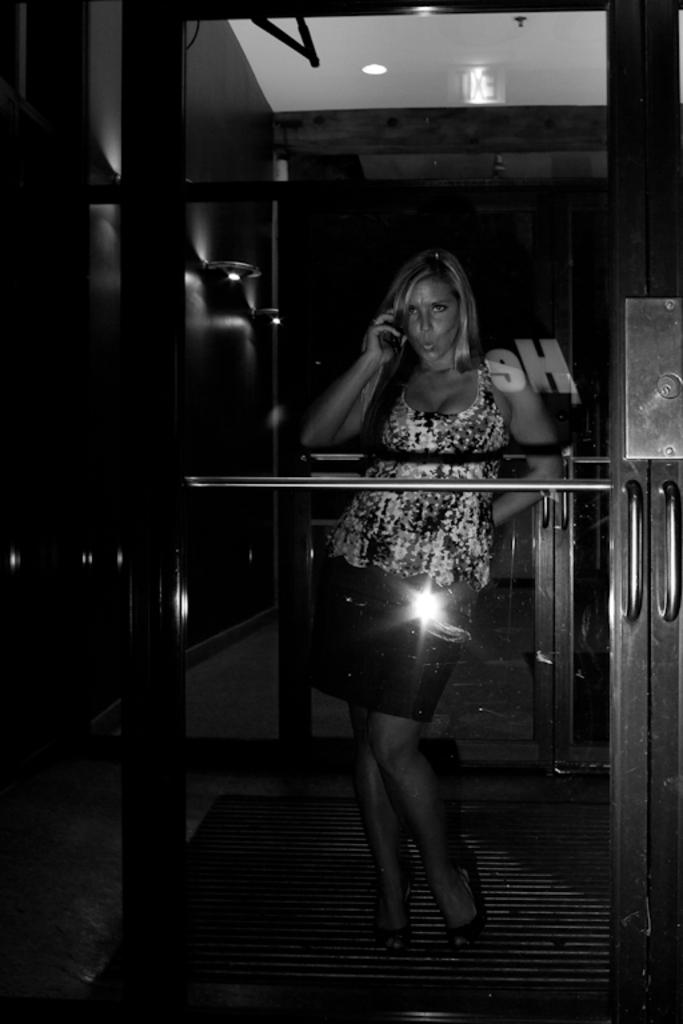What is the main subject of the image? There is a person standing in the image. What type of door is visible in the image? There is a glass door in the image. What is the color scheme of the image? The image is in black and white. What type of land can be seen through the glass door in the image? There is no land visible through the glass door in the image, as it is in black and white and does not show any outdoor scenery. 